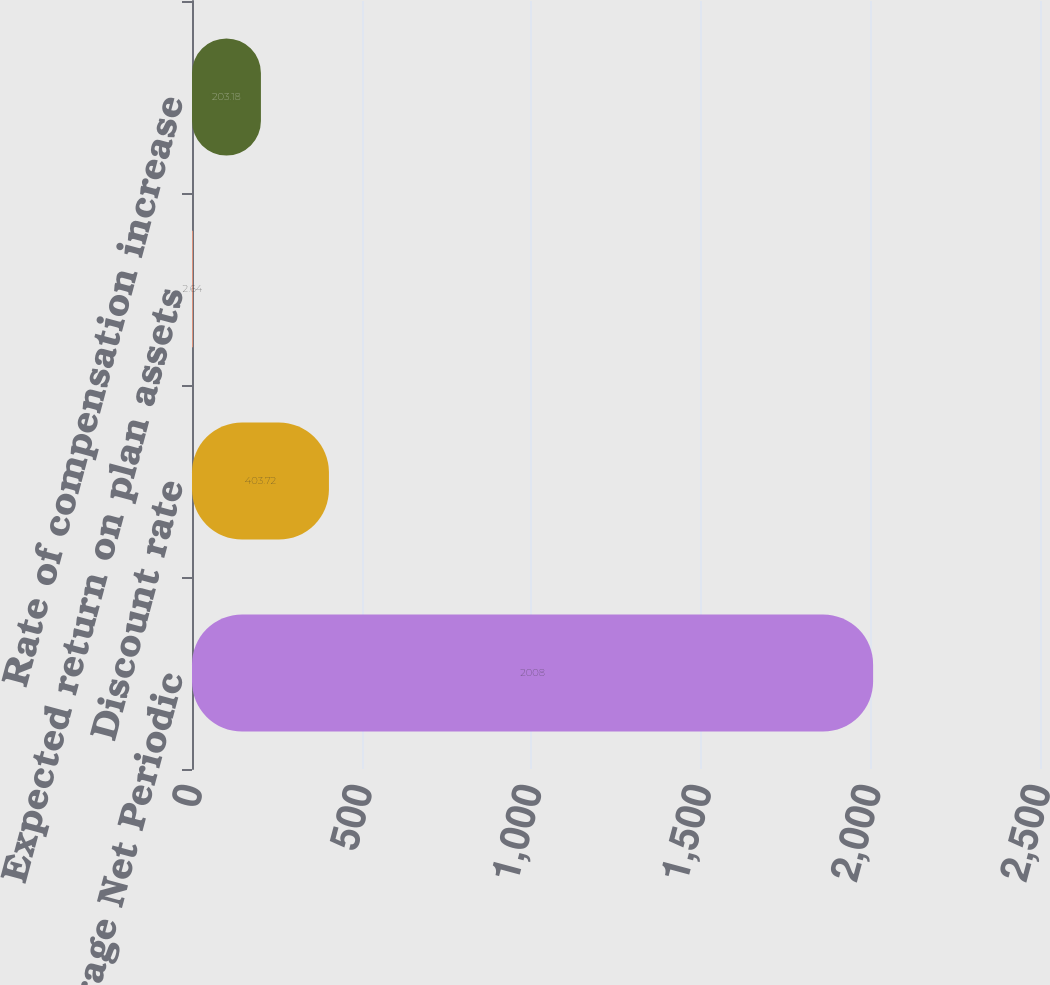Convert chart. <chart><loc_0><loc_0><loc_500><loc_500><bar_chart><fcel>Weighted-Average Net Periodic<fcel>Discount rate<fcel>Expected return on plan assets<fcel>Rate of compensation increase<nl><fcel>2008<fcel>403.72<fcel>2.64<fcel>203.18<nl></chart> 